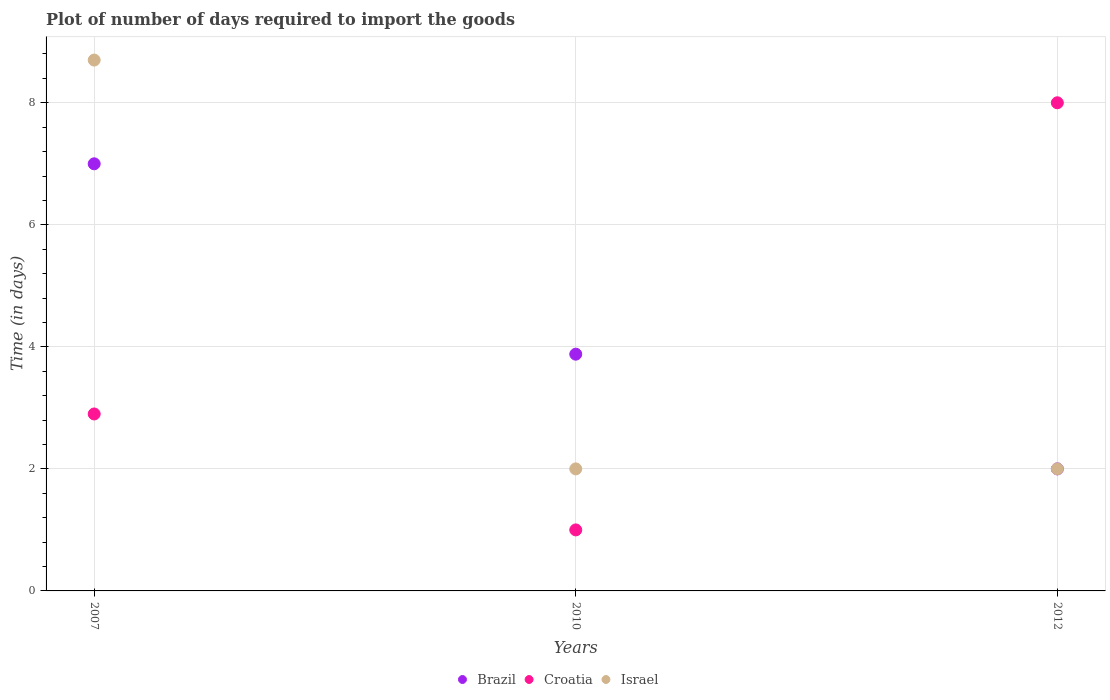How many different coloured dotlines are there?
Make the answer very short. 3. Is the number of dotlines equal to the number of legend labels?
Offer a terse response. Yes. What is the time required to import goods in Brazil in 2012?
Offer a very short reply. 2. In which year was the time required to import goods in Brazil maximum?
Your answer should be very brief. 2007. What is the difference between the time required to import goods in Israel in 2012 and the time required to import goods in Croatia in 2007?
Offer a terse response. -0.9. What is the average time required to import goods in Croatia per year?
Make the answer very short. 3.97. In how many years, is the time required to import goods in Brazil greater than 6.8 days?
Your answer should be compact. 1. What is the ratio of the time required to import goods in Israel in 2007 to that in 2012?
Keep it short and to the point. 4.35. Is the difference between the time required to import goods in Israel in 2007 and 2012 greater than the difference between the time required to import goods in Croatia in 2007 and 2012?
Your answer should be very brief. Yes. What is the difference between the highest and the second highest time required to import goods in Israel?
Offer a very short reply. 6.7. What is the difference between the highest and the lowest time required to import goods in Brazil?
Offer a very short reply. 5. In how many years, is the time required to import goods in Israel greater than the average time required to import goods in Israel taken over all years?
Your response must be concise. 1. Is the sum of the time required to import goods in Israel in 2007 and 2010 greater than the maximum time required to import goods in Croatia across all years?
Your answer should be very brief. Yes. How many dotlines are there?
Offer a terse response. 3. How many years are there in the graph?
Make the answer very short. 3. What is the difference between two consecutive major ticks on the Y-axis?
Give a very brief answer. 2. Does the graph contain grids?
Your response must be concise. Yes. How many legend labels are there?
Give a very brief answer. 3. What is the title of the graph?
Your answer should be compact. Plot of number of days required to import the goods. Does "Greece" appear as one of the legend labels in the graph?
Provide a short and direct response. No. What is the label or title of the X-axis?
Ensure brevity in your answer.  Years. What is the label or title of the Y-axis?
Your response must be concise. Time (in days). What is the Time (in days) in Brazil in 2007?
Your answer should be compact. 7. What is the Time (in days) of Israel in 2007?
Provide a short and direct response. 8.7. What is the Time (in days) of Brazil in 2010?
Give a very brief answer. 3.88. What is the Time (in days) in Croatia in 2010?
Ensure brevity in your answer.  1. What is the Time (in days) of Israel in 2010?
Your answer should be very brief. 2. What is the Time (in days) of Brazil in 2012?
Your response must be concise. 2. Across all years, what is the minimum Time (in days) of Croatia?
Your answer should be very brief. 1. Across all years, what is the minimum Time (in days) in Israel?
Your answer should be compact. 2. What is the total Time (in days) in Brazil in the graph?
Your response must be concise. 12.88. What is the total Time (in days) in Israel in the graph?
Provide a short and direct response. 12.7. What is the difference between the Time (in days) of Brazil in 2007 and that in 2010?
Give a very brief answer. 3.12. What is the difference between the Time (in days) in Israel in 2007 and that in 2010?
Provide a succinct answer. 6.7. What is the difference between the Time (in days) in Brazil in 2007 and that in 2012?
Keep it short and to the point. 5. What is the difference between the Time (in days) in Brazil in 2010 and that in 2012?
Make the answer very short. 1.88. What is the difference between the Time (in days) of Israel in 2010 and that in 2012?
Give a very brief answer. 0. What is the difference between the Time (in days) in Brazil in 2007 and the Time (in days) in Croatia in 2010?
Your response must be concise. 6. What is the difference between the Time (in days) in Croatia in 2007 and the Time (in days) in Israel in 2010?
Your response must be concise. 0.9. What is the difference between the Time (in days) in Brazil in 2007 and the Time (in days) in Israel in 2012?
Give a very brief answer. 5. What is the difference between the Time (in days) of Croatia in 2007 and the Time (in days) of Israel in 2012?
Make the answer very short. 0.9. What is the difference between the Time (in days) in Brazil in 2010 and the Time (in days) in Croatia in 2012?
Make the answer very short. -4.12. What is the difference between the Time (in days) of Brazil in 2010 and the Time (in days) of Israel in 2012?
Your answer should be very brief. 1.88. What is the average Time (in days) in Brazil per year?
Provide a succinct answer. 4.29. What is the average Time (in days) in Croatia per year?
Ensure brevity in your answer.  3.97. What is the average Time (in days) in Israel per year?
Make the answer very short. 4.23. In the year 2007, what is the difference between the Time (in days) of Brazil and Time (in days) of Croatia?
Keep it short and to the point. 4.1. In the year 2010, what is the difference between the Time (in days) of Brazil and Time (in days) of Croatia?
Make the answer very short. 2.88. In the year 2010, what is the difference between the Time (in days) in Brazil and Time (in days) in Israel?
Offer a very short reply. 1.88. In the year 2012, what is the difference between the Time (in days) of Brazil and Time (in days) of Croatia?
Offer a very short reply. -6. In the year 2012, what is the difference between the Time (in days) of Brazil and Time (in days) of Israel?
Offer a terse response. 0. What is the ratio of the Time (in days) in Brazil in 2007 to that in 2010?
Your answer should be compact. 1.8. What is the ratio of the Time (in days) of Croatia in 2007 to that in 2010?
Your response must be concise. 2.9. What is the ratio of the Time (in days) of Israel in 2007 to that in 2010?
Give a very brief answer. 4.35. What is the ratio of the Time (in days) of Brazil in 2007 to that in 2012?
Give a very brief answer. 3.5. What is the ratio of the Time (in days) in Croatia in 2007 to that in 2012?
Give a very brief answer. 0.36. What is the ratio of the Time (in days) of Israel in 2007 to that in 2012?
Make the answer very short. 4.35. What is the ratio of the Time (in days) in Brazil in 2010 to that in 2012?
Provide a succinct answer. 1.94. What is the difference between the highest and the second highest Time (in days) of Brazil?
Keep it short and to the point. 3.12. What is the difference between the highest and the second highest Time (in days) in Croatia?
Give a very brief answer. 5.1. What is the difference between the highest and the lowest Time (in days) of Israel?
Your answer should be very brief. 6.7. 